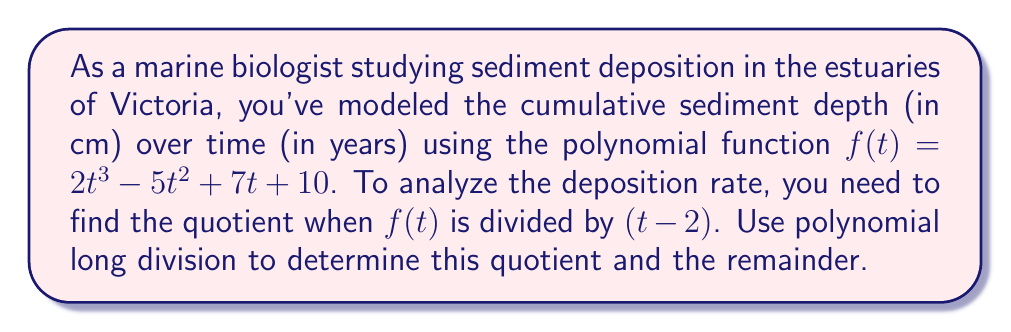Help me with this question. Let's perform polynomial long division of $f(t) = 2t^3 - 5t^2 + 7t + 10$ by $(t-2)$:

$$
\begin{array}{r}
2t^2 + 4t + 15 \\
t - 2 \enclose{longdiv}{2t^3 - 5t^2 + 7t + 10} \\
\underline{2t^3 - 4t^2} \\
-t^2 + 7t \\
\underline{-t^2 + 2t} \\
5t + 10 \\
\underline{5t - 10} \\
20
\end{array}
$$

Step 1: Divide $2t^3$ by $t$ to get $2t^2$. Multiply $(t-2)$ by $2t^2$:
$2t^2(t-2) = 2t^3 - 4t^2$

Step 2: Subtract $2t^3 - 4t^2$ from $2t^3 - 5t^2$:
$2t^3 - 5t^2 - (2t^3 - 4t^2) = -t^2 + 7t$

Step 3: Bring down the $7t$ term. Divide $-t^2$ by $t$ to get $-t$. Multiply $(t-2)$ by $-t$:
$-t(t-2) = -t^2 + 2t$

Step 4: Subtract $-t^2 + 2t$ from $-t^2 + 7t$:
$-t^2 + 7t - (-t^2 + 2t) = 5t + 10$

Step 5: Divide $5t$ by $t$ to get $5$. Multiply $(t-2)$ by $5$:
$5(t-2) = 5t - 10$

Step 6: Subtract $5t - 10$ from $5t + 10$:
$5t + 10 - (5t - 10) = 20$

The division is complete. The quotient is $2t^2 + 4t + 15$ and the remainder is $20$.
Answer: Quotient: $2t^2 + 4t + 15$
Remainder: $20$ 